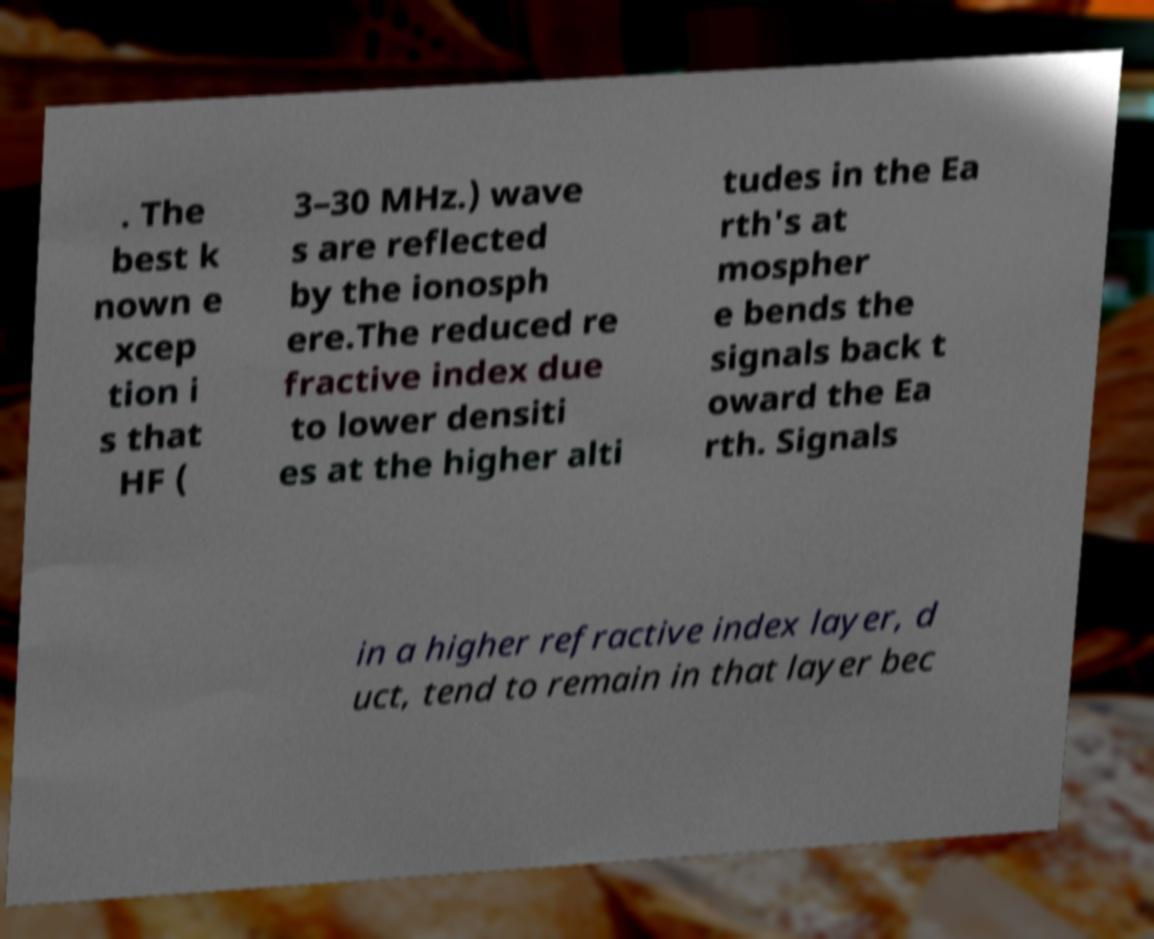I need the written content from this picture converted into text. Can you do that? . The best k nown e xcep tion i s that HF ( 3–30 MHz.) wave s are reflected by the ionosph ere.The reduced re fractive index due to lower densiti es at the higher alti tudes in the Ea rth's at mospher e bends the signals back t oward the Ea rth. Signals in a higher refractive index layer, d uct, tend to remain in that layer bec 